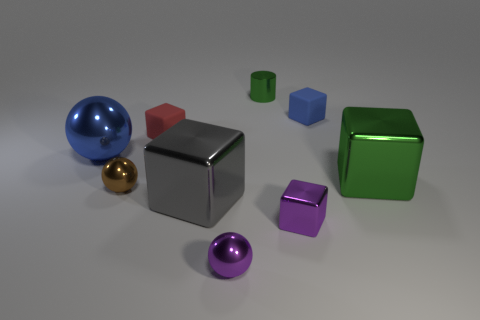Can you tell me what colors the objects are? Certainly! The objects present a variety of colors: there's a blue sphere, a red cube, a green cube, a reflective silver cube, a gold sphere, a purple cube, and a pink sphere. Each color is vibrant and adds to the visual appeal of the scene. 